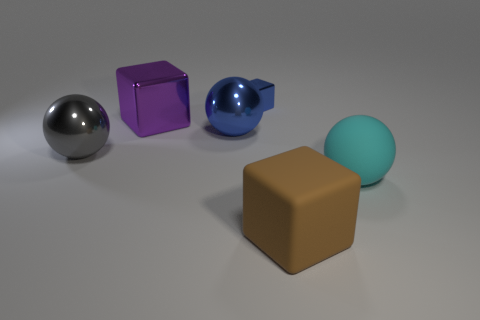There is a big cube that is behind the big gray shiny object; what material is it? The cube behind the large gray shiny sphere appears to be made of a type of plastic, indicated by its matte finish and solid color, which are common characteristics of plastic materials used for objects in visual renderings or illustrations. 